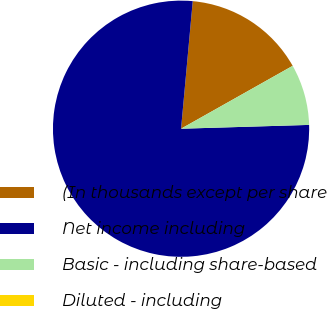Convert chart. <chart><loc_0><loc_0><loc_500><loc_500><pie_chart><fcel>(In thousands except per share<fcel>Net income including<fcel>Basic - including share-based<fcel>Diluted - including<nl><fcel>15.38%<fcel>76.92%<fcel>7.69%<fcel>0.0%<nl></chart> 